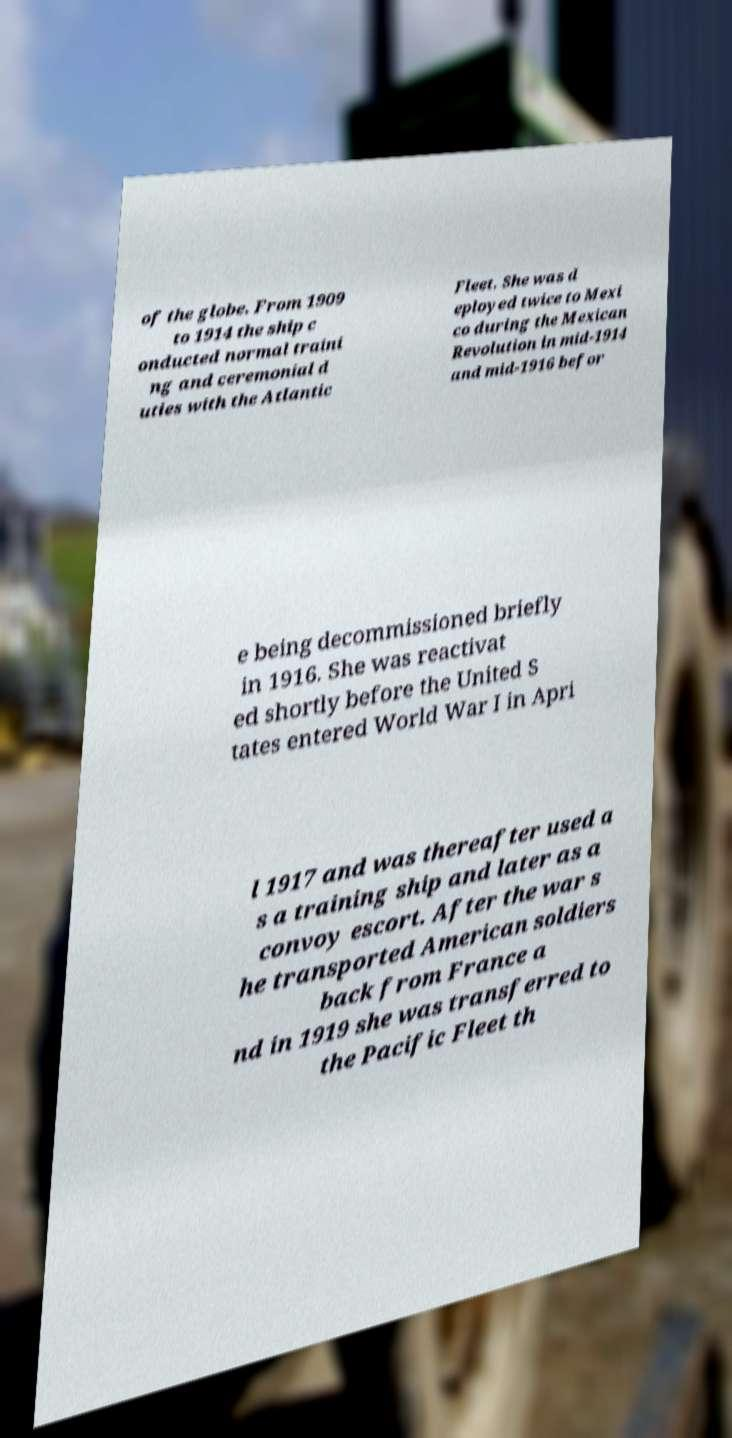Please identify and transcribe the text found in this image. of the globe. From 1909 to 1914 the ship c onducted normal traini ng and ceremonial d uties with the Atlantic Fleet. She was d eployed twice to Mexi co during the Mexican Revolution in mid-1914 and mid-1916 befor e being decommissioned briefly in 1916. She was reactivat ed shortly before the United S tates entered World War I in Apri l 1917 and was thereafter used a s a training ship and later as a convoy escort. After the war s he transported American soldiers back from France a nd in 1919 she was transferred to the Pacific Fleet th 